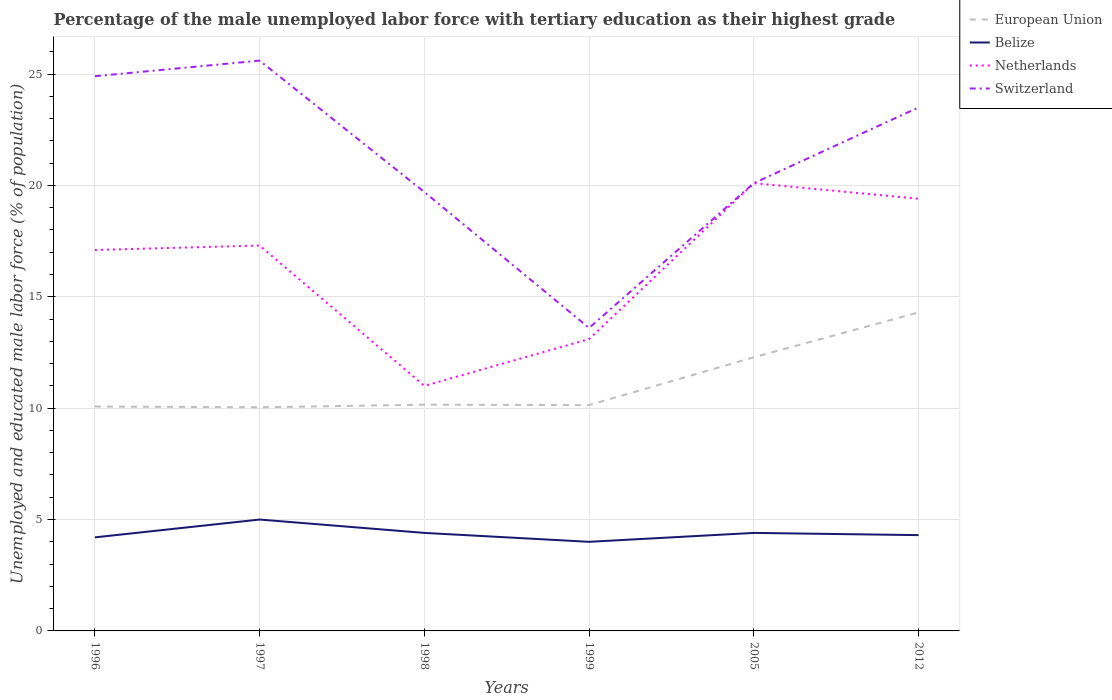Across all years, what is the maximum percentage of the unemployed male labor force with tertiary education in Switzerland?
Ensure brevity in your answer.  13.6. What is the total percentage of the unemployed male labor force with tertiary education in Switzerland in the graph?
Your answer should be compact. -6.5. How many lines are there?
Offer a very short reply. 4. What is the difference between two consecutive major ticks on the Y-axis?
Ensure brevity in your answer.  5. Where does the legend appear in the graph?
Provide a short and direct response. Top right. How are the legend labels stacked?
Provide a succinct answer. Vertical. What is the title of the graph?
Your answer should be very brief. Percentage of the male unemployed labor force with tertiary education as their highest grade. What is the label or title of the X-axis?
Make the answer very short. Years. What is the label or title of the Y-axis?
Make the answer very short. Unemployed and educated male labor force (% of population). What is the Unemployed and educated male labor force (% of population) in European Union in 1996?
Keep it short and to the point. 10.07. What is the Unemployed and educated male labor force (% of population) in Belize in 1996?
Your response must be concise. 4.2. What is the Unemployed and educated male labor force (% of population) in Netherlands in 1996?
Your answer should be very brief. 17.1. What is the Unemployed and educated male labor force (% of population) of Switzerland in 1996?
Make the answer very short. 24.9. What is the Unemployed and educated male labor force (% of population) of European Union in 1997?
Your response must be concise. 10.04. What is the Unemployed and educated male labor force (% of population) in Netherlands in 1997?
Your response must be concise. 17.3. What is the Unemployed and educated male labor force (% of population) in Switzerland in 1997?
Provide a succinct answer. 25.6. What is the Unemployed and educated male labor force (% of population) of European Union in 1998?
Provide a succinct answer. 10.16. What is the Unemployed and educated male labor force (% of population) in Belize in 1998?
Give a very brief answer. 4.4. What is the Unemployed and educated male labor force (% of population) of Switzerland in 1998?
Provide a short and direct response. 19.7. What is the Unemployed and educated male labor force (% of population) of European Union in 1999?
Your answer should be very brief. 10.14. What is the Unemployed and educated male labor force (% of population) in Belize in 1999?
Keep it short and to the point. 4. What is the Unemployed and educated male labor force (% of population) of Netherlands in 1999?
Your answer should be very brief. 13.1. What is the Unemployed and educated male labor force (% of population) in Switzerland in 1999?
Offer a very short reply. 13.6. What is the Unemployed and educated male labor force (% of population) of European Union in 2005?
Your answer should be compact. 12.28. What is the Unemployed and educated male labor force (% of population) in Belize in 2005?
Your answer should be compact. 4.4. What is the Unemployed and educated male labor force (% of population) of Netherlands in 2005?
Ensure brevity in your answer.  20.1. What is the Unemployed and educated male labor force (% of population) of Switzerland in 2005?
Your answer should be compact. 20.1. What is the Unemployed and educated male labor force (% of population) of European Union in 2012?
Offer a terse response. 14.3. What is the Unemployed and educated male labor force (% of population) in Belize in 2012?
Your response must be concise. 4.3. What is the Unemployed and educated male labor force (% of population) of Netherlands in 2012?
Provide a succinct answer. 19.4. What is the Unemployed and educated male labor force (% of population) in Switzerland in 2012?
Ensure brevity in your answer.  23.5. Across all years, what is the maximum Unemployed and educated male labor force (% of population) in European Union?
Make the answer very short. 14.3. Across all years, what is the maximum Unemployed and educated male labor force (% of population) in Netherlands?
Ensure brevity in your answer.  20.1. Across all years, what is the maximum Unemployed and educated male labor force (% of population) of Switzerland?
Keep it short and to the point. 25.6. Across all years, what is the minimum Unemployed and educated male labor force (% of population) of European Union?
Provide a short and direct response. 10.04. Across all years, what is the minimum Unemployed and educated male labor force (% of population) of Belize?
Offer a terse response. 4. Across all years, what is the minimum Unemployed and educated male labor force (% of population) in Switzerland?
Provide a succinct answer. 13.6. What is the total Unemployed and educated male labor force (% of population) of European Union in the graph?
Your response must be concise. 66.99. What is the total Unemployed and educated male labor force (% of population) in Belize in the graph?
Offer a terse response. 26.3. What is the total Unemployed and educated male labor force (% of population) of Netherlands in the graph?
Provide a succinct answer. 98. What is the total Unemployed and educated male labor force (% of population) in Switzerland in the graph?
Make the answer very short. 127.4. What is the difference between the Unemployed and educated male labor force (% of population) in European Union in 1996 and that in 1997?
Give a very brief answer. 0.04. What is the difference between the Unemployed and educated male labor force (% of population) of European Union in 1996 and that in 1998?
Give a very brief answer. -0.08. What is the difference between the Unemployed and educated male labor force (% of population) of Switzerland in 1996 and that in 1998?
Keep it short and to the point. 5.2. What is the difference between the Unemployed and educated male labor force (% of population) in European Union in 1996 and that in 1999?
Offer a terse response. -0.06. What is the difference between the Unemployed and educated male labor force (% of population) in Belize in 1996 and that in 1999?
Your response must be concise. 0.2. What is the difference between the Unemployed and educated male labor force (% of population) of Netherlands in 1996 and that in 1999?
Your answer should be very brief. 4. What is the difference between the Unemployed and educated male labor force (% of population) of Switzerland in 1996 and that in 1999?
Make the answer very short. 11.3. What is the difference between the Unemployed and educated male labor force (% of population) of European Union in 1996 and that in 2005?
Offer a very short reply. -2.21. What is the difference between the Unemployed and educated male labor force (% of population) of Belize in 1996 and that in 2005?
Offer a terse response. -0.2. What is the difference between the Unemployed and educated male labor force (% of population) of Netherlands in 1996 and that in 2005?
Offer a very short reply. -3. What is the difference between the Unemployed and educated male labor force (% of population) in European Union in 1996 and that in 2012?
Ensure brevity in your answer.  -4.22. What is the difference between the Unemployed and educated male labor force (% of population) in Switzerland in 1996 and that in 2012?
Your response must be concise. 1.4. What is the difference between the Unemployed and educated male labor force (% of population) in European Union in 1997 and that in 1998?
Your answer should be compact. -0.12. What is the difference between the Unemployed and educated male labor force (% of population) of Netherlands in 1997 and that in 1998?
Offer a very short reply. 6.3. What is the difference between the Unemployed and educated male labor force (% of population) of Switzerland in 1997 and that in 1998?
Offer a terse response. 5.9. What is the difference between the Unemployed and educated male labor force (% of population) in European Union in 1997 and that in 1999?
Provide a succinct answer. -0.1. What is the difference between the Unemployed and educated male labor force (% of population) of Belize in 1997 and that in 1999?
Keep it short and to the point. 1. What is the difference between the Unemployed and educated male labor force (% of population) in Switzerland in 1997 and that in 1999?
Offer a terse response. 12. What is the difference between the Unemployed and educated male labor force (% of population) in European Union in 1997 and that in 2005?
Your answer should be very brief. -2.25. What is the difference between the Unemployed and educated male labor force (% of population) in Netherlands in 1997 and that in 2005?
Give a very brief answer. -2.8. What is the difference between the Unemployed and educated male labor force (% of population) of European Union in 1997 and that in 2012?
Your answer should be compact. -4.26. What is the difference between the Unemployed and educated male labor force (% of population) of European Union in 1998 and that in 1999?
Provide a succinct answer. 0.02. What is the difference between the Unemployed and educated male labor force (% of population) in Netherlands in 1998 and that in 1999?
Your answer should be compact. -2.1. What is the difference between the Unemployed and educated male labor force (% of population) of Switzerland in 1998 and that in 1999?
Keep it short and to the point. 6.1. What is the difference between the Unemployed and educated male labor force (% of population) of European Union in 1998 and that in 2005?
Your response must be concise. -2.13. What is the difference between the Unemployed and educated male labor force (% of population) in Belize in 1998 and that in 2005?
Offer a terse response. 0. What is the difference between the Unemployed and educated male labor force (% of population) in Netherlands in 1998 and that in 2005?
Give a very brief answer. -9.1. What is the difference between the Unemployed and educated male labor force (% of population) in European Union in 1998 and that in 2012?
Ensure brevity in your answer.  -4.14. What is the difference between the Unemployed and educated male labor force (% of population) in Netherlands in 1998 and that in 2012?
Keep it short and to the point. -8.4. What is the difference between the Unemployed and educated male labor force (% of population) of European Union in 1999 and that in 2005?
Your answer should be very brief. -2.14. What is the difference between the Unemployed and educated male labor force (% of population) of Belize in 1999 and that in 2005?
Provide a short and direct response. -0.4. What is the difference between the Unemployed and educated male labor force (% of population) in Netherlands in 1999 and that in 2005?
Give a very brief answer. -7. What is the difference between the Unemployed and educated male labor force (% of population) of Switzerland in 1999 and that in 2005?
Offer a very short reply. -6.5. What is the difference between the Unemployed and educated male labor force (% of population) of European Union in 1999 and that in 2012?
Provide a succinct answer. -4.16. What is the difference between the Unemployed and educated male labor force (% of population) of Belize in 1999 and that in 2012?
Provide a succinct answer. -0.3. What is the difference between the Unemployed and educated male labor force (% of population) of Netherlands in 1999 and that in 2012?
Offer a very short reply. -6.3. What is the difference between the Unemployed and educated male labor force (% of population) of European Union in 2005 and that in 2012?
Keep it short and to the point. -2.01. What is the difference between the Unemployed and educated male labor force (% of population) of Netherlands in 2005 and that in 2012?
Your response must be concise. 0.7. What is the difference between the Unemployed and educated male labor force (% of population) in Switzerland in 2005 and that in 2012?
Provide a short and direct response. -3.4. What is the difference between the Unemployed and educated male labor force (% of population) in European Union in 1996 and the Unemployed and educated male labor force (% of population) in Belize in 1997?
Your response must be concise. 5.07. What is the difference between the Unemployed and educated male labor force (% of population) in European Union in 1996 and the Unemployed and educated male labor force (% of population) in Netherlands in 1997?
Offer a terse response. -7.23. What is the difference between the Unemployed and educated male labor force (% of population) in European Union in 1996 and the Unemployed and educated male labor force (% of population) in Switzerland in 1997?
Make the answer very short. -15.53. What is the difference between the Unemployed and educated male labor force (% of population) in Belize in 1996 and the Unemployed and educated male labor force (% of population) in Netherlands in 1997?
Ensure brevity in your answer.  -13.1. What is the difference between the Unemployed and educated male labor force (% of population) of Belize in 1996 and the Unemployed and educated male labor force (% of population) of Switzerland in 1997?
Keep it short and to the point. -21.4. What is the difference between the Unemployed and educated male labor force (% of population) in European Union in 1996 and the Unemployed and educated male labor force (% of population) in Belize in 1998?
Give a very brief answer. 5.67. What is the difference between the Unemployed and educated male labor force (% of population) of European Union in 1996 and the Unemployed and educated male labor force (% of population) of Netherlands in 1998?
Offer a terse response. -0.93. What is the difference between the Unemployed and educated male labor force (% of population) in European Union in 1996 and the Unemployed and educated male labor force (% of population) in Switzerland in 1998?
Provide a succinct answer. -9.63. What is the difference between the Unemployed and educated male labor force (% of population) of Belize in 1996 and the Unemployed and educated male labor force (% of population) of Switzerland in 1998?
Provide a succinct answer. -15.5. What is the difference between the Unemployed and educated male labor force (% of population) in European Union in 1996 and the Unemployed and educated male labor force (% of population) in Belize in 1999?
Your answer should be compact. 6.07. What is the difference between the Unemployed and educated male labor force (% of population) of European Union in 1996 and the Unemployed and educated male labor force (% of population) of Netherlands in 1999?
Offer a terse response. -3.03. What is the difference between the Unemployed and educated male labor force (% of population) of European Union in 1996 and the Unemployed and educated male labor force (% of population) of Switzerland in 1999?
Your answer should be very brief. -3.53. What is the difference between the Unemployed and educated male labor force (% of population) in Belize in 1996 and the Unemployed and educated male labor force (% of population) in Netherlands in 1999?
Make the answer very short. -8.9. What is the difference between the Unemployed and educated male labor force (% of population) of Netherlands in 1996 and the Unemployed and educated male labor force (% of population) of Switzerland in 1999?
Ensure brevity in your answer.  3.5. What is the difference between the Unemployed and educated male labor force (% of population) of European Union in 1996 and the Unemployed and educated male labor force (% of population) of Belize in 2005?
Your answer should be compact. 5.67. What is the difference between the Unemployed and educated male labor force (% of population) of European Union in 1996 and the Unemployed and educated male labor force (% of population) of Netherlands in 2005?
Your response must be concise. -10.03. What is the difference between the Unemployed and educated male labor force (% of population) of European Union in 1996 and the Unemployed and educated male labor force (% of population) of Switzerland in 2005?
Offer a very short reply. -10.03. What is the difference between the Unemployed and educated male labor force (% of population) of Belize in 1996 and the Unemployed and educated male labor force (% of population) of Netherlands in 2005?
Provide a succinct answer. -15.9. What is the difference between the Unemployed and educated male labor force (% of population) in Belize in 1996 and the Unemployed and educated male labor force (% of population) in Switzerland in 2005?
Provide a short and direct response. -15.9. What is the difference between the Unemployed and educated male labor force (% of population) of European Union in 1996 and the Unemployed and educated male labor force (% of population) of Belize in 2012?
Provide a short and direct response. 5.77. What is the difference between the Unemployed and educated male labor force (% of population) of European Union in 1996 and the Unemployed and educated male labor force (% of population) of Netherlands in 2012?
Make the answer very short. -9.33. What is the difference between the Unemployed and educated male labor force (% of population) in European Union in 1996 and the Unemployed and educated male labor force (% of population) in Switzerland in 2012?
Provide a short and direct response. -13.43. What is the difference between the Unemployed and educated male labor force (% of population) in Belize in 1996 and the Unemployed and educated male labor force (% of population) in Netherlands in 2012?
Your answer should be very brief. -15.2. What is the difference between the Unemployed and educated male labor force (% of population) of Belize in 1996 and the Unemployed and educated male labor force (% of population) of Switzerland in 2012?
Your response must be concise. -19.3. What is the difference between the Unemployed and educated male labor force (% of population) in Netherlands in 1996 and the Unemployed and educated male labor force (% of population) in Switzerland in 2012?
Provide a succinct answer. -6.4. What is the difference between the Unemployed and educated male labor force (% of population) of European Union in 1997 and the Unemployed and educated male labor force (% of population) of Belize in 1998?
Offer a very short reply. 5.64. What is the difference between the Unemployed and educated male labor force (% of population) in European Union in 1997 and the Unemployed and educated male labor force (% of population) in Netherlands in 1998?
Your answer should be very brief. -0.96. What is the difference between the Unemployed and educated male labor force (% of population) of European Union in 1997 and the Unemployed and educated male labor force (% of population) of Switzerland in 1998?
Your answer should be very brief. -9.66. What is the difference between the Unemployed and educated male labor force (% of population) in Belize in 1997 and the Unemployed and educated male labor force (% of population) in Switzerland in 1998?
Your answer should be very brief. -14.7. What is the difference between the Unemployed and educated male labor force (% of population) of European Union in 1997 and the Unemployed and educated male labor force (% of population) of Belize in 1999?
Your answer should be very brief. 6.04. What is the difference between the Unemployed and educated male labor force (% of population) of European Union in 1997 and the Unemployed and educated male labor force (% of population) of Netherlands in 1999?
Make the answer very short. -3.06. What is the difference between the Unemployed and educated male labor force (% of population) in European Union in 1997 and the Unemployed and educated male labor force (% of population) in Switzerland in 1999?
Ensure brevity in your answer.  -3.56. What is the difference between the Unemployed and educated male labor force (% of population) in European Union in 1997 and the Unemployed and educated male labor force (% of population) in Belize in 2005?
Give a very brief answer. 5.64. What is the difference between the Unemployed and educated male labor force (% of population) in European Union in 1997 and the Unemployed and educated male labor force (% of population) in Netherlands in 2005?
Offer a terse response. -10.06. What is the difference between the Unemployed and educated male labor force (% of population) of European Union in 1997 and the Unemployed and educated male labor force (% of population) of Switzerland in 2005?
Provide a succinct answer. -10.06. What is the difference between the Unemployed and educated male labor force (% of population) of Belize in 1997 and the Unemployed and educated male labor force (% of population) of Netherlands in 2005?
Make the answer very short. -15.1. What is the difference between the Unemployed and educated male labor force (% of population) in Belize in 1997 and the Unemployed and educated male labor force (% of population) in Switzerland in 2005?
Provide a succinct answer. -15.1. What is the difference between the Unemployed and educated male labor force (% of population) of Netherlands in 1997 and the Unemployed and educated male labor force (% of population) of Switzerland in 2005?
Ensure brevity in your answer.  -2.8. What is the difference between the Unemployed and educated male labor force (% of population) of European Union in 1997 and the Unemployed and educated male labor force (% of population) of Belize in 2012?
Offer a very short reply. 5.74. What is the difference between the Unemployed and educated male labor force (% of population) of European Union in 1997 and the Unemployed and educated male labor force (% of population) of Netherlands in 2012?
Keep it short and to the point. -9.36. What is the difference between the Unemployed and educated male labor force (% of population) in European Union in 1997 and the Unemployed and educated male labor force (% of population) in Switzerland in 2012?
Offer a very short reply. -13.46. What is the difference between the Unemployed and educated male labor force (% of population) of Belize in 1997 and the Unemployed and educated male labor force (% of population) of Netherlands in 2012?
Provide a short and direct response. -14.4. What is the difference between the Unemployed and educated male labor force (% of population) in Belize in 1997 and the Unemployed and educated male labor force (% of population) in Switzerland in 2012?
Provide a succinct answer. -18.5. What is the difference between the Unemployed and educated male labor force (% of population) of European Union in 1998 and the Unemployed and educated male labor force (% of population) of Belize in 1999?
Your answer should be very brief. 6.16. What is the difference between the Unemployed and educated male labor force (% of population) of European Union in 1998 and the Unemployed and educated male labor force (% of population) of Netherlands in 1999?
Offer a very short reply. -2.94. What is the difference between the Unemployed and educated male labor force (% of population) in European Union in 1998 and the Unemployed and educated male labor force (% of population) in Switzerland in 1999?
Offer a terse response. -3.44. What is the difference between the Unemployed and educated male labor force (% of population) of Belize in 1998 and the Unemployed and educated male labor force (% of population) of Netherlands in 1999?
Make the answer very short. -8.7. What is the difference between the Unemployed and educated male labor force (% of population) in Netherlands in 1998 and the Unemployed and educated male labor force (% of population) in Switzerland in 1999?
Ensure brevity in your answer.  -2.6. What is the difference between the Unemployed and educated male labor force (% of population) in European Union in 1998 and the Unemployed and educated male labor force (% of population) in Belize in 2005?
Ensure brevity in your answer.  5.76. What is the difference between the Unemployed and educated male labor force (% of population) in European Union in 1998 and the Unemployed and educated male labor force (% of population) in Netherlands in 2005?
Your answer should be very brief. -9.94. What is the difference between the Unemployed and educated male labor force (% of population) of European Union in 1998 and the Unemployed and educated male labor force (% of population) of Switzerland in 2005?
Provide a short and direct response. -9.94. What is the difference between the Unemployed and educated male labor force (% of population) of Belize in 1998 and the Unemployed and educated male labor force (% of population) of Netherlands in 2005?
Your response must be concise. -15.7. What is the difference between the Unemployed and educated male labor force (% of population) of Belize in 1998 and the Unemployed and educated male labor force (% of population) of Switzerland in 2005?
Provide a succinct answer. -15.7. What is the difference between the Unemployed and educated male labor force (% of population) of European Union in 1998 and the Unemployed and educated male labor force (% of population) of Belize in 2012?
Make the answer very short. 5.86. What is the difference between the Unemployed and educated male labor force (% of population) of European Union in 1998 and the Unemployed and educated male labor force (% of population) of Netherlands in 2012?
Keep it short and to the point. -9.24. What is the difference between the Unemployed and educated male labor force (% of population) in European Union in 1998 and the Unemployed and educated male labor force (% of population) in Switzerland in 2012?
Give a very brief answer. -13.34. What is the difference between the Unemployed and educated male labor force (% of population) of Belize in 1998 and the Unemployed and educated male labor force (% of population) of Netherlands in 2012?
Your answer should be very brief. -15. What is the difference between the Unemployed and educated male labor force (% of population) in Belize in 1998 and the Unemployed and educated male labor force (% of population) in Switzerland in 2012?
Offer a very short reply. -19.1. What is the difference between the Unemployed and educated male labor force (% of population) in European Union in 1999 and the Unemployed and educated male labor force (% of population) in Belize in 2005?
Ensure brevity in your answer.  5.74. What is the difference between the Unemployed and educated male labor force (% of population) in European Union in 1999 and the Unemployed and educated male labor force (% of population) in Netherlands in 2005?
Offer a terse response. -9.96. What is the difference between the Unemployed and educated male labor force (% of population) of European Union in 1999 and the Unemployed and educated male labor force (% of population) of Switzerland in 2005?
Your answer should be compact. -9.96. What is the difference between the Unemployed and educated male labor force (% of population) in Belize in 1999 and the Unemployed and educated male labor force (% of population) in Netherlands in 2005?
Your answer should be compact. -16.1. What is the difference between the Unemployed and educated male labor force (% of population) in Belize in 1999 and the Unemployed and educated male labor force (% of population) in Switzerland in 2005?
Give a very brief answer. -16.1. What is the difference between the Unemployed and educated male labor force (% of population) in European Union in 1999 and the Unemployed and educated male labor force (% of population) in Belize in 2012?
Your response must be concise. 5.84. What is the difference between the Unemployed and educated male labor force (% of population) in European Union in 1999 and the Unemployed and educated male labor force (% of population) in Netherlands in 2012?
Provide a short and direct response. -9.26. What is the difference between the Unemployed and educated male labor force (% of population) of European Union in 1999 and the Unemployed and educated male labor force (% of population) of Switzerland in 2012?
Give a very brief answer. -13.36. What is the difference between the Unemployed and educated male labor force (% of population) in Belize in 1999 and the Unemployed and educated male labor force (% of population) in Netherlands in 2012?
Provide a short and direct response. -15.4. What is the difference between the Unemployed and educated male labor force (% of population) in Belize in 1999 and the Unemployed and educated male labor force (% of population) in Switzerland in 2012?
Keep it short and to the point. -19.5. What is the difference between the Unemployed and educated male labor force (% of population) of Netherlands in 1999 and the Unemployed and educated male labor force (% of population) of Switzerland in 2012?
Your response must be concise. -10.4. What is the difference between the Unemployed and educated male labor force (% of population) in European Union in 2005 and the Unemployed and educated male labor force (% of population) in Belize in 2012?
Your answer should be compact. 7.98. What is the difference between the Unemployed and educated male labor force (% of population) of European Union in 2005 and the Unemployed and educated male labor force (% of population) of Netherlands in 2012?
Your answer should be very brief. -7.12. What is the difference between the Unemployed and educated male labor force (% of population) of European Union in 2005 and the Unemployed and educated male labor force (% of population) of Switzerland in 2012?
Keep it short and to the point. -11.22. What is the difference between the Unemployed and educated male labor force (% of population) of Belize in 2005 and the Unemployed and educated male labor force (% of population) of Switzerland in 2012?
Provide a succinct answer. -19.1. What is the average Unemployed and educated male labor force (% of population) of European Union per year?
Offer a terse response. 11.16. What is the average Unemployed and educated male labor force (% of population) in Belize per year?
Offer a very short reply. 4.38. What is the average Unemployed and educated male labor force (% of population) of Netherlands per year?
Give a very brief answer. 16.33. What is the average Unemployed and educated male labor force (% of population) of Switzerland per year?
Keep it short and to the point. 21.23. In the year 1996, what is the difference between the Unemployed and educated male labor force (% of population) of European Union and Unemployed and educated male labor force (% of population) of Belize?
Ensure brevity in your answer.  5.87. In the year 1996, what is the difference between the Unemployed and educated male labor force (% of population) of European Union and Unemployed and educated male labor force (% of population) of Netherlands?
Give a very brief answer. -7.03. In the year 1996, what is the difference between the Unemployed and educated male labor force (% of population) in European Union and Unemployed and educated male labor force (% of population) in Switzerland?
Your response must be concise. -14.83. In the year 1996, what is the difference between the Unemployed and educated male labor force (% of population) of Belize and Unemployed and educated male labor force (% of population) of Switzerland?
Offer a very short reply. -20.7. In the year 1996, what is the difference between the Unemployed and educated male labor force (% of population) in Netherlands and Unemployed and educated male labor force (% of population) in Switzerland?
Ensure brevity in your answer.  -7.8. In the year 1997, what is the difference between the Unemployed and educated male labor force (% of population) of European Union and Unemployed and educated male labor force (% of population) of Belize?
Keep it short and to the point. 5.04. In the year 1997, what is the difference between the Unemployed and educated male labor force (% of population) in European Union and Unemployed and educated male labor force (% of population) in Netherlands?
Provide a succinct answer. -7.26. In the year 1997, what is the difference between the Unemployed and educated male labor force (% of population) of European Union and Unemployed and educated male labor force (% of population) of Switzerland?
Offer a very short reply. -15.56. In the year 1997, what is the difference between the Unemployed and educated male labor force (% of population) in Belize and Unemployed and educated male labor force (% of population) in Netherlands?
Make the answer very short. -12.3. In the year 1997, what is the difference between the Unemployed and educated male labor force (% of population) in Belize and Unemployed and educated male labor force (% of population) in Switzerland?
Keep it short and to the point. -20.6. In the year 1998, what is the difference between the Unemployed and educated male labor force (% of population) in European Union and Unemployed and educated male labor force (% of population) in Belize?
Provide a short and direct response. 5.76. In the year 1998, what is the difference between the Unemployed and educated male labor force (% of population) of European Union and Unemployed and educated male labor force (% of population) of Netherlands?
Keep it short and to the point. -0.84. In the year 1998, what is the difference between the Unemployed and educated male labor force (% of population) of European Union and Unemployed and educated male labor force (% of population) of Switzerland?
Offer a terse response. -9.54. In the year 1998, what is the difference between the Unemployed and educated male labor force (% of population) of Belize and Unemployed and educated male labor force (% of population) of Switzerland?
Ensure brevity in your answer.  -15.3. In the year 1999, what is the difference between the Unemployed and educated male labor force (% of population) of European Union and Unemployed and educated male labor force (% of population) of Belize?
Keep it short and to the point. 6.14. In the year 1999, what is the difference between the Unemployed and educated male labor force (% of population) in European Union and Unemployed and educated male labor force (% of population) in Netherlands?
Make the answer very short. -2.96. In the year 1999, what is the difference between the Unemployed and educated male labor force (% of population) of European Union and Unemployed and educated male labor force (% of population) of Switzerland?
Ensure brevity in your answer.  -3.46. In the year 1999, what is the difference between the Unemployed and educated male labor force (% of population) in Belize and Unemployed and educated male labor force (% of population) in Switzerland?
Your answer should be compact. -9.6. In the year 1999, what is the difference between the Unemployed and educated male labor force (% of population) in Netherlands and Unemployed and educated male labor force (% of population) in Switzerland?
Give a very brief answer. -0.5. In the year 2005, what is the difference between the Unemployed and educated male labor force (% of population) of European Union and Unemployed and educated male labor force (% of population) of Belize?
Keep it short and to the point. 7.88. In the year 2005, what is the difference between the Unemployed and educated male labor force (% of population) of European Union and Unemployed and educated male labor force (% of population) of Netherlands?
Give a very brief answer. -7.82. In the year 2005, what is the difference between the Unemployed and educated male labor force (% of population) of European Union and Unemployed and educated male labor force (% of population) of Switzerland?
Keep it short and to the point. -7.82. In the year 2005, what is the difference between the Unemployed and educated male labor force (% of population) in Belize and Unemployed and educated male labor force (% of population) in Netherlands?
Keep it short and to the point. -15.7. In the year 2005, what is the difference between the Unemployed and educated male labor force (% of population) in Belize and Unemployed and educated male labor force (% of population) in Switzerland?
Your response must be concise. -15.7. In the year 2005, what is the difference between the Unemployed and educated male labor force (% of population) of Netherlands and Unemployed and educated male labor force (% of population) of Switzerland?
Offer a very short reply. 0. In the year 2012, what is the difference between the Unemployed and educated male labor force (% of population) of European Union and Unemployed and educated male labor force (% of population) of Belize?
Offer a terse response. 10. In the year 2012, what is the difference between the Unemployed and educated male labor force (% of population) in European Union and Unemployed and educated male labor force (% of population) in Netherlands?
Offer a very short reply. -5.1. In the year 2012, what is the difference between the Unemployed and educated male labor force (% of population) of European Union and Unemployed and educated male labor force (% of population) of Switzerland?
Your answer should be compact. -9.2. In the year 2012, what is the difference between the Unemployed and educated male labor force (% of population) in Belize and Unemployed and educated male labor force (% of population) in Netherlands?
Your answer should be very brief. -15.1. In the year 2012, what is the difference between the Unemployed and educated male labor force (% of population) in Belize and Unemployed and educated male labor force (% of population) in Switzerland?
Ensure brevity in your answer.  -19.2. What is the ratio of the Unemployed and educated male labor force (% of population) of Belize in 1996 to that in 1997?
Offer a very short reply. 0.84. What is the ratio of the Unemployed and educated male labor force (% of population) of Netherlands in 1996 to that in 1997?
Offer a terse response. 0.99. What is the ratio of the Unemployed and educated male labor force (% of population) of Switzerland in 1996 to that in 1997?
Keep it short and to the point. 0.97. What is the ratio of the Unemployed and educated male labor force (% of population) of European Union in 1996 to that in 1998?
Make the answer very short. 0.99. What is the ratio of the Unemployed and educated male labor force (% of population) in Belize in 1996 to that in 1998?
Give a very brief answer. 0.95. What is the ratio of the Unemployed and educated male labor force (% of population) in Netherlands in 1996 to that in 1998?
Your answer should be compact. 1.55. What is the ratio of the Unemployed and educated male labor force (% of population) in Switzerland in 1996 to that in 1998?
Offer a terse response. 1.26. What is the ratio of the Unemployed and educated male labor force (% of population) in Belize in 1996 to that in 1999?
Provide a succinct answer. 1.05. What is the ratio of the Unemployed and educated male labor force (% of population) of Netherlands in 1996 to that in 1999?
Your answer should be very brief. 1.31. What is the ratio of the Unemployed and educated male labor force (% of population) of Switzerland in 1996 to that in 1999?
Your response must be concise. 1.83. What is the ratio of the Unemployed and educated male labor force (% of population) of European Union in 1996 to that in 2005?
Make the answer very short. 0.82. What is the ratio of the Unemployed and educated male labor force (% of population) of Belize in 1996 to that in 2005?
Provide a short and direct response. 0.95. What is the ratio of the Unemployed and educated male labor force (% of population) in Netherlands in 1996 to that in 2005?
Provide a short and direct response. 0.85. What is the ratio of the Unemployed and educated male labor force (% of population) of Switzerland in 1996 to that in 2005?
Your answer should be very brief. 1.24. What is the ratio of the Unemployed and educated male labor force (% of population) in European Union in 1996 to that in 2012?
Provide a succinct answer. 0.7. What is the ratio of the Unemployed and educated male labor force (% of population) of Belize in 1996 to that in 2012?
Your answer should be very brief. 0.98. What is the ratio of the Unemployed and educated male labor force (% of population) of Netherlands in 1996 to that in 2012?
Your response must be concise. 0.88. What is the ratio of the Unemployed and educated male labor force (% of population) of Switzerland in 1996 to that in 2012?
Give a very brief answer. 1.06. What is the ratio of the Unemployed and educated male labor force (% of population) in European Union in 1997 to that in 1998?
Offer a very short reply. 0.99. What is the ratio of the Unemployed and educated male labor force (% of population) of Belize in 1997 to that in 1998?
Offer a terse response. 1.14. What is the ratio of the Unemployed and educated male labor force (% of population) in Netherlands in 1997 to that in 1998?
Provide a succinct answer. 1.57. What is the ratio of the Unemployed and educated male labor force (% of population) in Switzerland in 1997 to that in 1998?
Keep it short and to the point. 1.3. What is the ratio of the Unemployed and educated male labor force (% of population) of European Union in 1997 to that in 1999?
Ensure brevity in your answer.  0.99. What is the ratio of the Unemployed and educated male labor force (% of population) in Belize in 1997 to that in 1999?
Your answer should be very brief. 1.25. What is the ratio of the Unemployed and educated male labor force (% of population) in Netherlands in 1997 to that in 1999?
Provide a succinct answer. 1.32. What is the ratio of the Unemployed and educated male labor force (% of population) in Switzerland in 1997 to that in 1999?
Provide a succinct answer. 1.88. What is the ratio of the Unemployed and educated male labor force (% of population) of European Union in 1997 to that in 2005?
Ensure brevity in your answer.  0.82. What is the ratio of the Unemployed and educated male labor force (% of population) of Belize in 1997 to that in 2005?
Your response must be concise. 1.14. What is the ratio of the Unemployed and educated male labor force (% of population) in Netherlands in 1997 to that in 2005?
Provide a succinct answer. 0.86. What is the ratio of the Unemployed and educated male labor force (% of population) in Switzerland in 1997 to that in 2005?
Offer a very short reply. 1.27. What is the ratio of the Unemployed and educated male labor force (% of population) in European Union in 1997 to that in 2012?
Provide a succinct answer. 0.7. What is the ratio of the Unemployed and educated male labor force (% of population) in Belize in 1997 to that in 2012?
Your response must be concise. 1.16. What is the ratio of the Unemployed and educated male labor force (% of population) in Netherlands in 1997 to that in 2012?
Make the answer very short. 0.89. What is the ratio of the Unemployed and educated male labor force (% of population) in Switzerland in 1997 to that in 2012?
Ensure brevity in your answer.  1.09. What is the ratio of the Unemployed and educated male labor force (% of population) of European Union in 1998 to that in 1999?
Your answer should be compact. 1. What is the ratio of the Unemployed and educated male labor force (% of population) in Belize in 1998 to that in 1999?
Your response must be concise. 1.1. What is the ratio of the Unemployed and educated male labor force (% of population) in Netherlands in 1998 to that in 1999?
Offer a terse response. 0.84. What is the ratio of the Unemployed and educated male labor force (% of population) in Switzerland in 1998 to that in 1999?
Your response must be concise. 1.45. What is the ratio of the Unemployed and educated male labor force (% of population) in European Union in 1998 to that in 2005?
Ensure brevity in your answer.  0.83. What is the ratio of the Unemployed and educated male labor force (% of population) in Belize in 1998 to that in 2005?
Provide a succinct answer. 1. What is the ratio of the Unemployed and educated male labor force (% of population) of Netherlands in 1998 to that in 2005?
Your response must be concise. 0.55. What is the ratio of the Unemployed and educated male labor force (% of population) in Switzerland in 1998 to that in 2005?
Provide a succinct answer. 0.98. What is the ratio of the Unemployed and educated male labor force (% of population) in European Union in 1998 to that in 2012?
Provide a short and direct response. 0.71. What is the ratio of the Unemployed and educated male labor force (% of population) of Belize in 1998 to that in 2012?
Offer a terse response. 1.02. What is the ratio of the Unemployed and educated male labor force (% of population) of Netherlands in 1998 to that in 2012?
Give a very brief answer. 0.57. What is the ratio of the Unemployed and educated male labor force (% of population) in Switzerland in 1998 to that in 2012?
Provide a short and direct response. 0.84. What is the ratio of the Unemployed and educated male labor force (% of population) in European Union in 1999 to that in 2005?
Provide a short and direct response. 0.83. What is the ratio of the Unemployed and educated male labor force (% of population) in Belize in 1999 to that in 2005?
Ensure brevity in your answer.  0.91. What is the ratio of the Unemployed and educated male labor force (% of population) of Netherlands in 1999 to that in 2005?
Your answer should be very brief. 0.65. What is the ratio of the Unemployed and educated male labor force (% of population) of Switzerland in 1999 to that in 2005?
Provide a short and direct response. 0.68. What is the ratio of the Unemployed and educated male labor force (% of population) of European Union in 1999 to that in 2012?
Make the answer very short. 0.71. What is the ratio of the Unemployed and educated male labor force (% of population) in Belize in 1999 to that in 2012?
Your answer should be compact. 0.93. What is the ratio of the Unemployed and educated male labor force (% of population) of Netherlands in 1999 to that in 2012?
Provide a short and direct response. 0.68. What is the ratio of the Unemployed and educated male labor force (% of population) of Switzerland in 1999 to that in 2012?
Give a very brief answer. 0.58. What is the ratio of the Unemployed and educated male labor force (% of population) in European Union in 2005 to that in 2012?
Give a very brief answer. 0.86. What is the ratio of the Unemployed and educated male labor force (% of population) of Belize in 2005 to that in 2012?
Offer a terse response. 1.02. What is the ratio of the Unemployed and educated male labor force (% of population) of Netherlands in 2005 to that in 2012?
Give a very brief answer. 1.04. What is the ratio of the Unemployed and educated male labor force (% of population) of Switzerland in 2005 to that in 2012?
Provide a short and direct response. 0.86. What is the difference between the highest and the second highest Unemployed and educated male labor force (% of population) in European Union?
Provide a succinct answer. 2.01. What is the difference between the highest and the second highest Unemployed and educated male labor force (% of population) of Belize?
Your answer should be very brief. 0.6. What is the difference between the highest and the second highest Unemployed and educated male labor force (% of population) in Netherlands?
Your answer should be very brief. 0.7. What is the difference between the highest and the second highest Unemployed and educated male labor force (% of population) in Switzerland?
Your response must be concise. 0.7. What is the difference between the highest and the lowest Unemployed and educated male labor force (% of population) of European Union?
Provide a succinct answer. 4.26. What is the difference between the highest and the lowest Unemployed and educated male labor force (% of population) in Switzerland?
Provide a short and direct response. 12. 